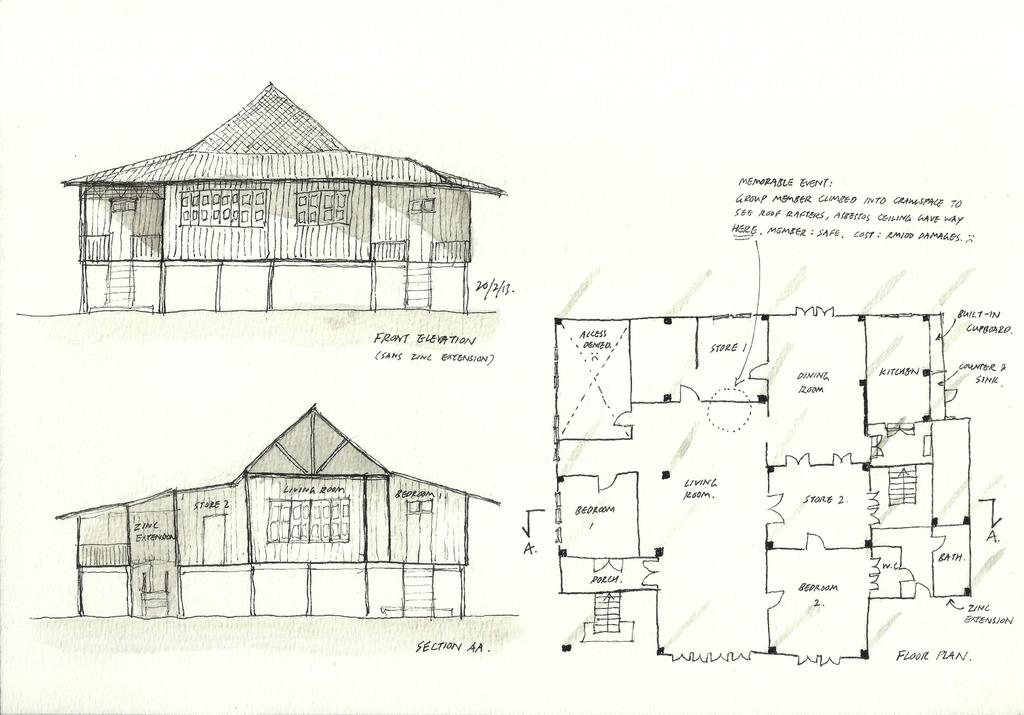What is depicted in the image? There is a sketch of two houses in the image. What color is the sketch? The sketch is in black color. What is located on the right side of the image? There is a floor plan on the right side of the image. What is written or drawn in black color in the image? Something is written in black color in the image. How many maids are present in the image? There are no maids present in the image; it features a sketch of two houses and a floor plan. What type of plant can be seen growing near the houses in the image? There is no plant visible in the image; it only contains a sketch of two houses and a floor plan. 